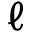Convert formula to latex. <formula><loc_0><loc_0><loc_500><loc_500>\ell</formula> 